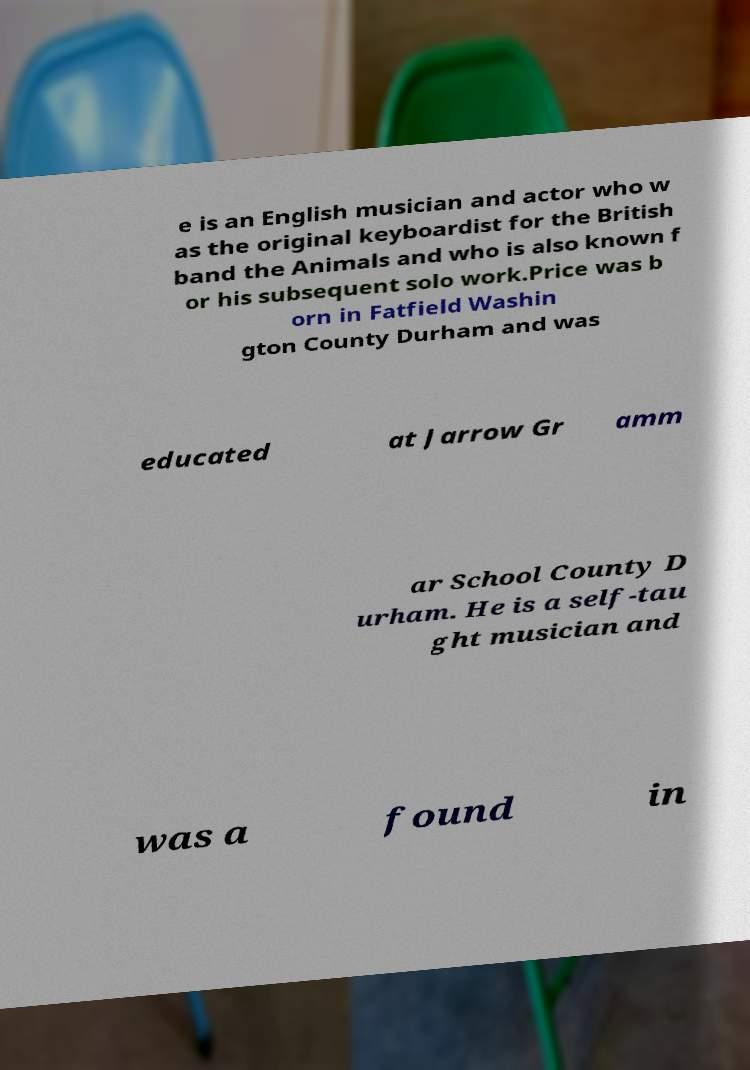Could you assist in decoding the text presented in this image and type it out clearly? e is an English musician and actor who w as the original keyboardist for the British band the Animals and who is also known f or his subsequent solo work.Price was b orn in Fatfield Washin gton County Durham and was educated at Jarrow Gr amm ar School County D urham. He is a self-tau ght musician and was a found in 